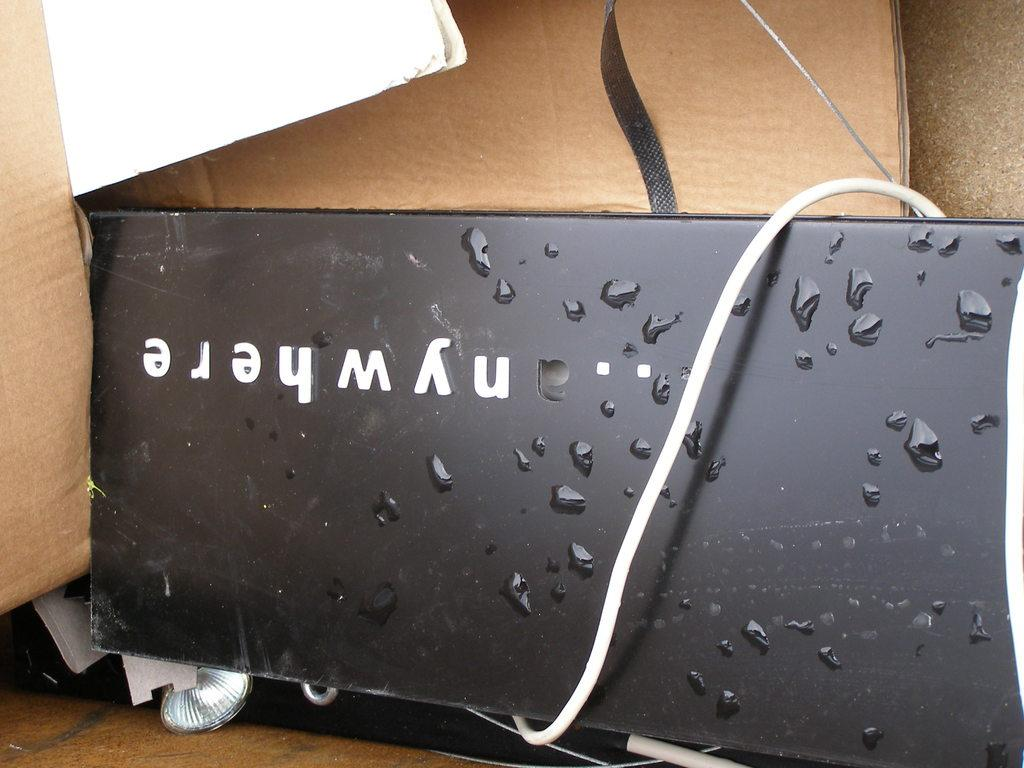<image>
Render a clear and concise summary of the photo. A nywhere labelled item has droplets of liquid on it. 